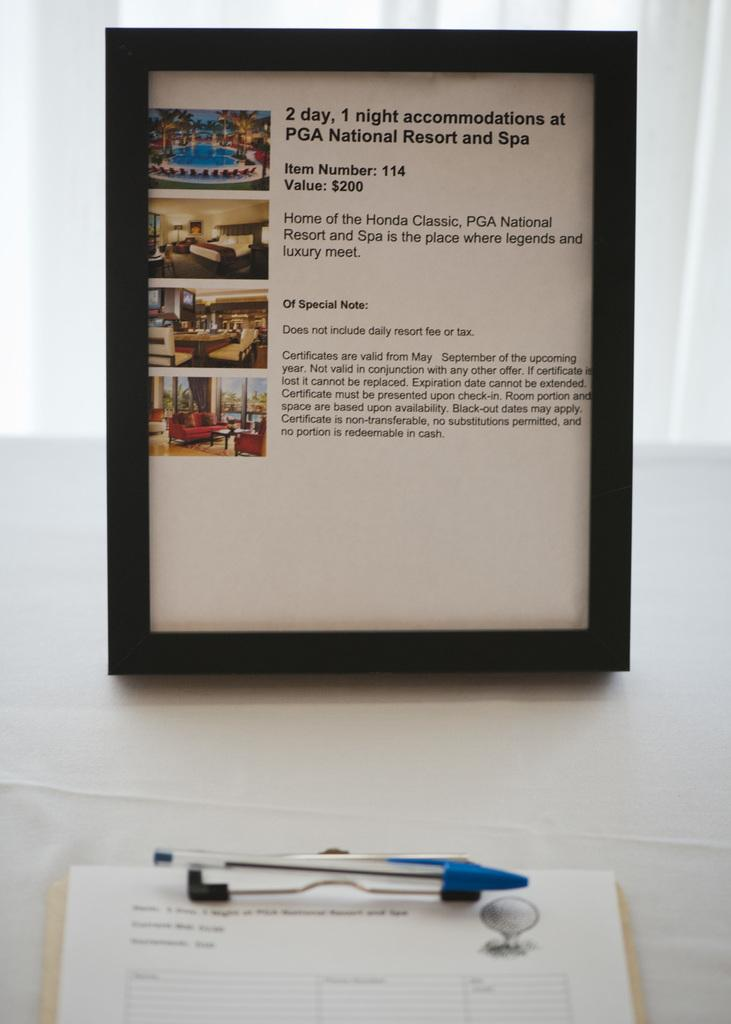What is the main object in the image? There is a board in the image. What is used for writing in the image? There is a pen in the image. What is the board placed on? The board is placed on a white color surface. What is the background color of the image? The background of the image is white. What other writing surface is present in the image? There is a pad in the image. What type of meal is being prepared on the board in the image? There is no meal being prepared in the image; the board is used for writing purposes. Can you see a pear on the board in the image? There is no pear present in the image. 